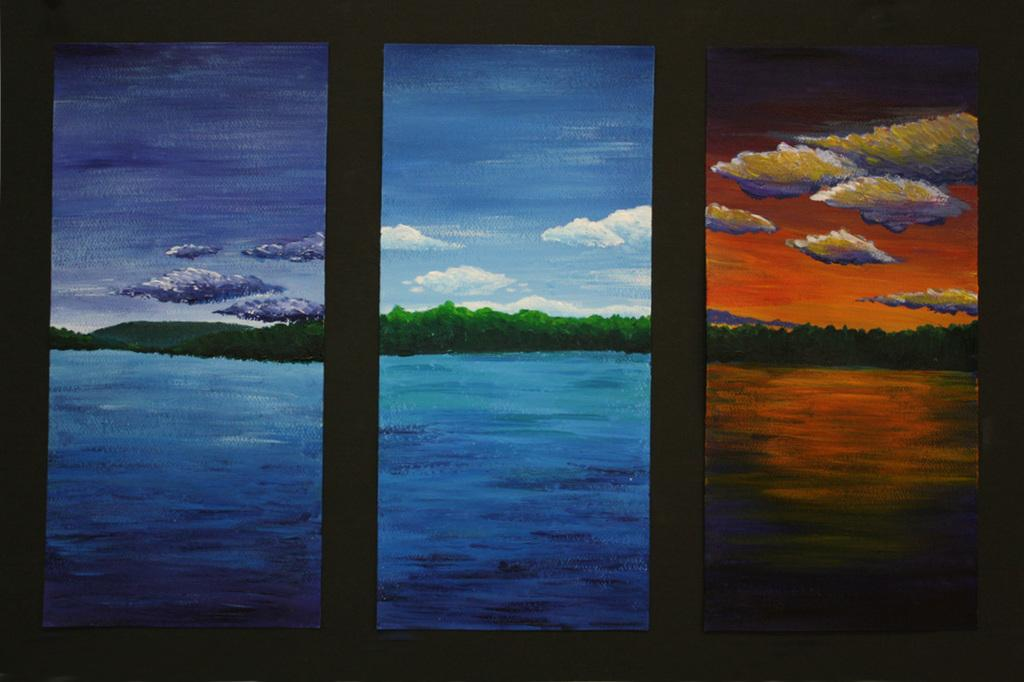What is on the wall in the image? There are paintings on the wall in the image. What subjects are depicted in the paintings? The paintings depict trees, hills, clouds in the sky, and water. Can you describe the landscape depicted in the paintings? The paintings depict a landscape with trees, hills, clouds, and water. Where is the kitten playing in the image? There is no kitten present in the image. What type of cloth is draped over the paintings in the image? There is no cloth draped over the paintings in the image. 